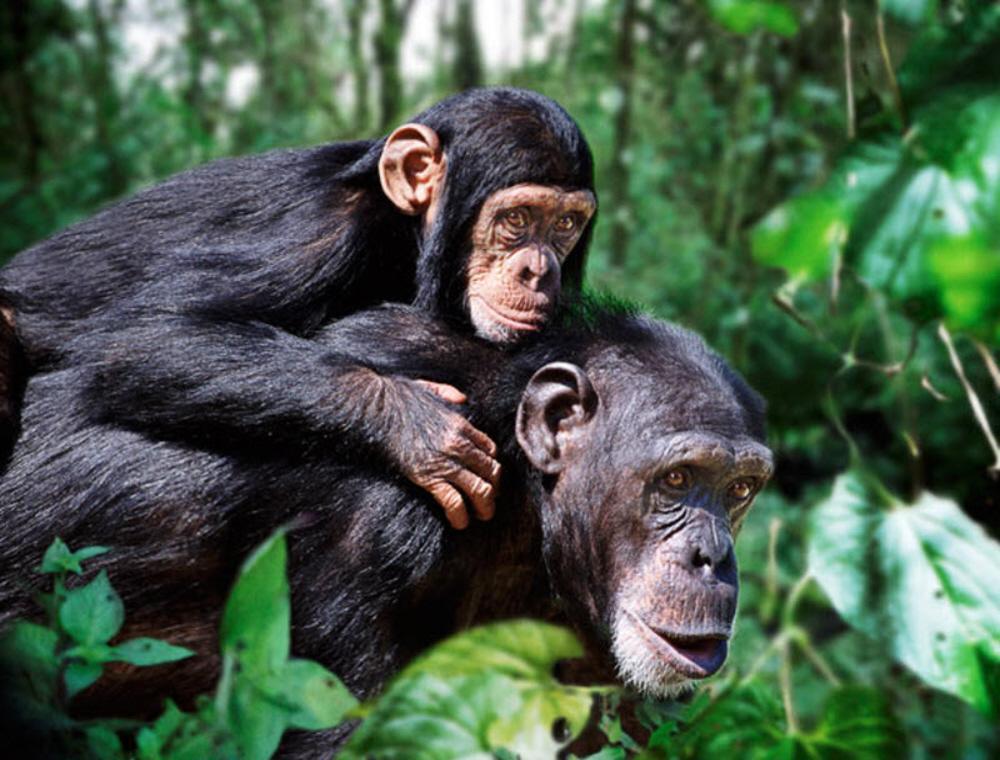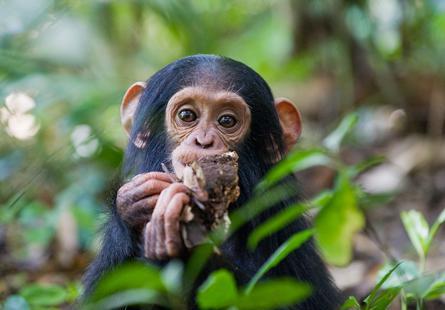The first image is the image on the left, the second image is the image on the right. Assess this claim about the two images: "One of the images contains a monkey that is holding its finger on its mouth.". Correct or not? Answer yes or no. No. 